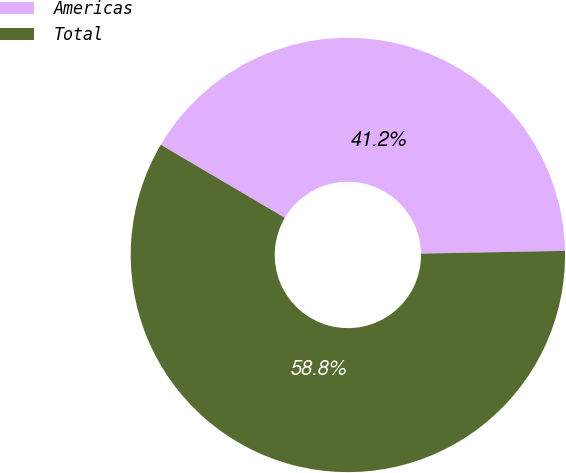Convert chart to OTSL. <chart><loc_0><loc_0><loc_500><loc_500><pie_chart><fcel>Americas<fcel>Total<nl><fcel>41.23%<fcel>58.77%<nl></chart> 